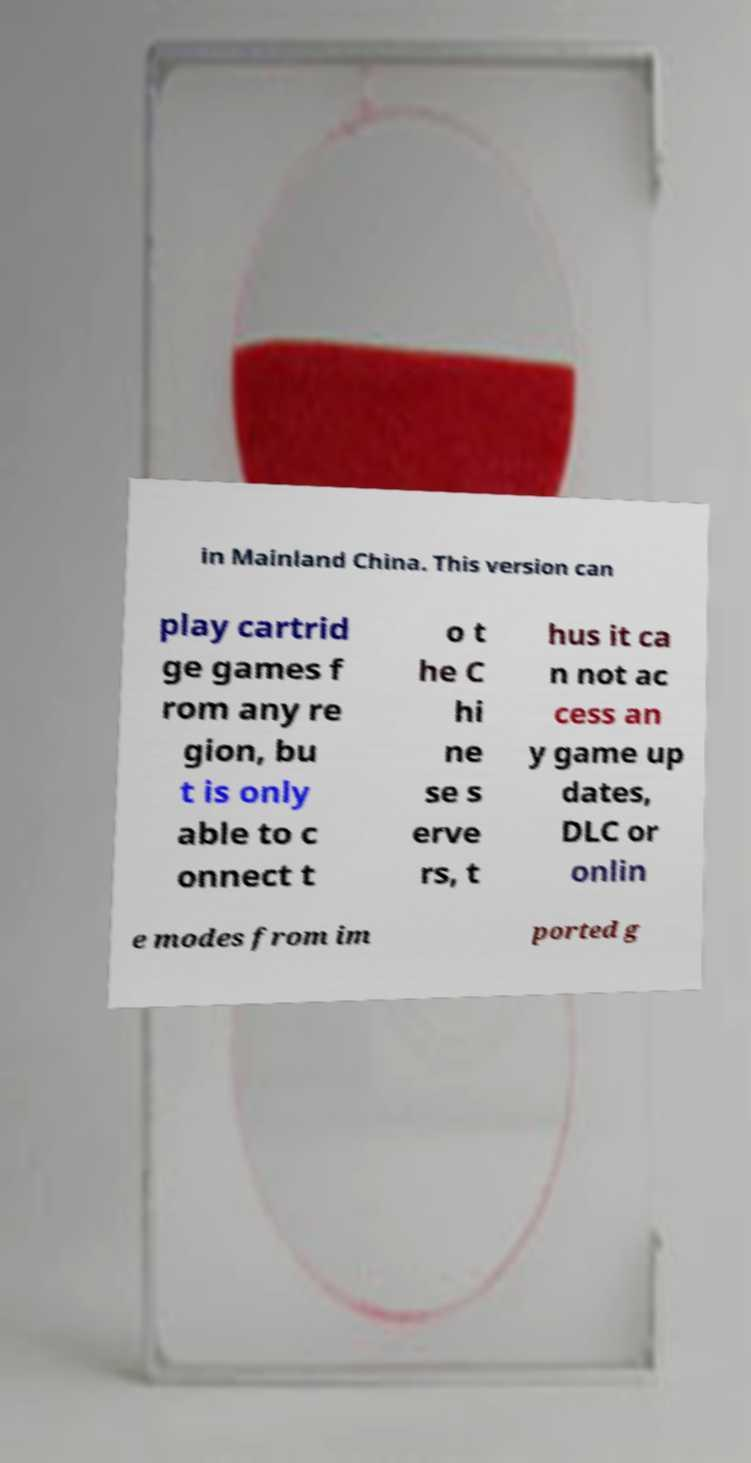Can you accurately transcribe the text from the provided image for me? in Mainland China. This version can play cartrid ge games f rom any re gion, bu t is only able to c onnect t o t he C hi ne se s erve rs, t hus it ca n not ac cess an y game up dates, DLC or onlin e modes from im ported g 